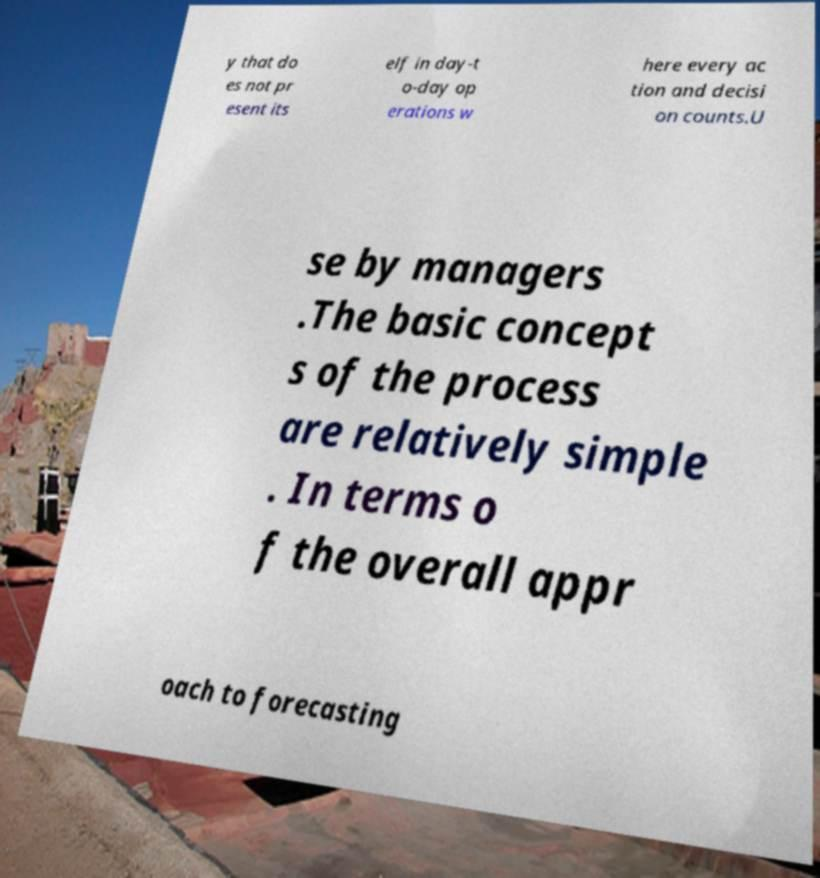What messages or text are displayed in this image? I need them in a readable, typed format. y that do es not pr esent its elf in day-t o-day op erations w here every ac tion and decisi on counts.U se by managers .The basic concept s of the process are relatively simple . In terms o f the overall appr oach to forecasting 